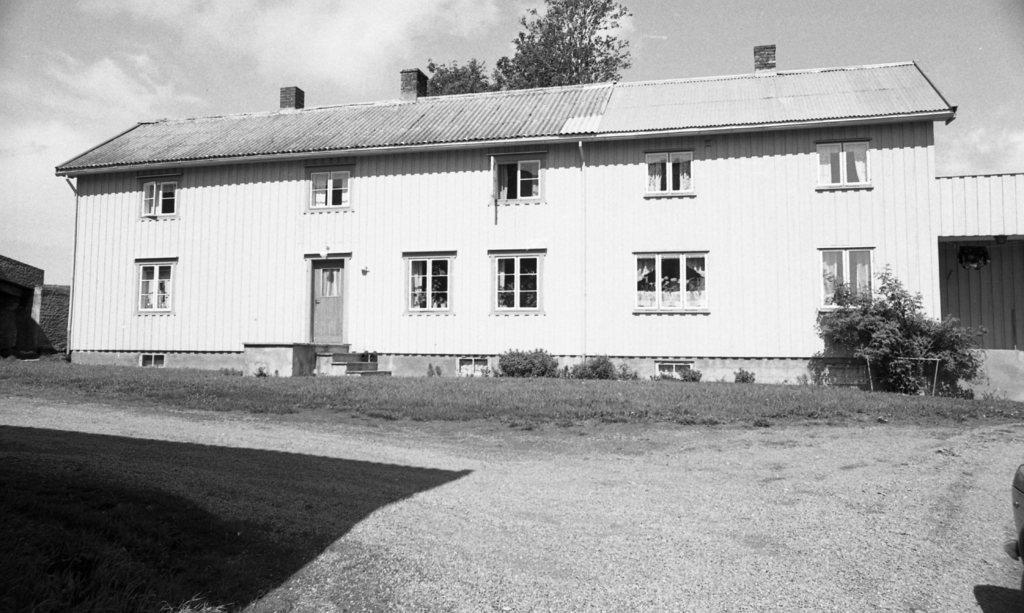What type of structure is visible in the image? There is a building in the image. What can be seen on the land in the image? There are plants on the land in the image. What is visible in the background of the image? There are trees and the sky in the background of the image. What is the condition of the sky in the image? The sky is visible in the background of the image, and there are clouds present. What is the color scheme of the image? The image is black and white. What type of sheet is draped over the building in the image? There is no sheet draped over the building in the image; it is a black and white photograph with no visible fabric. 